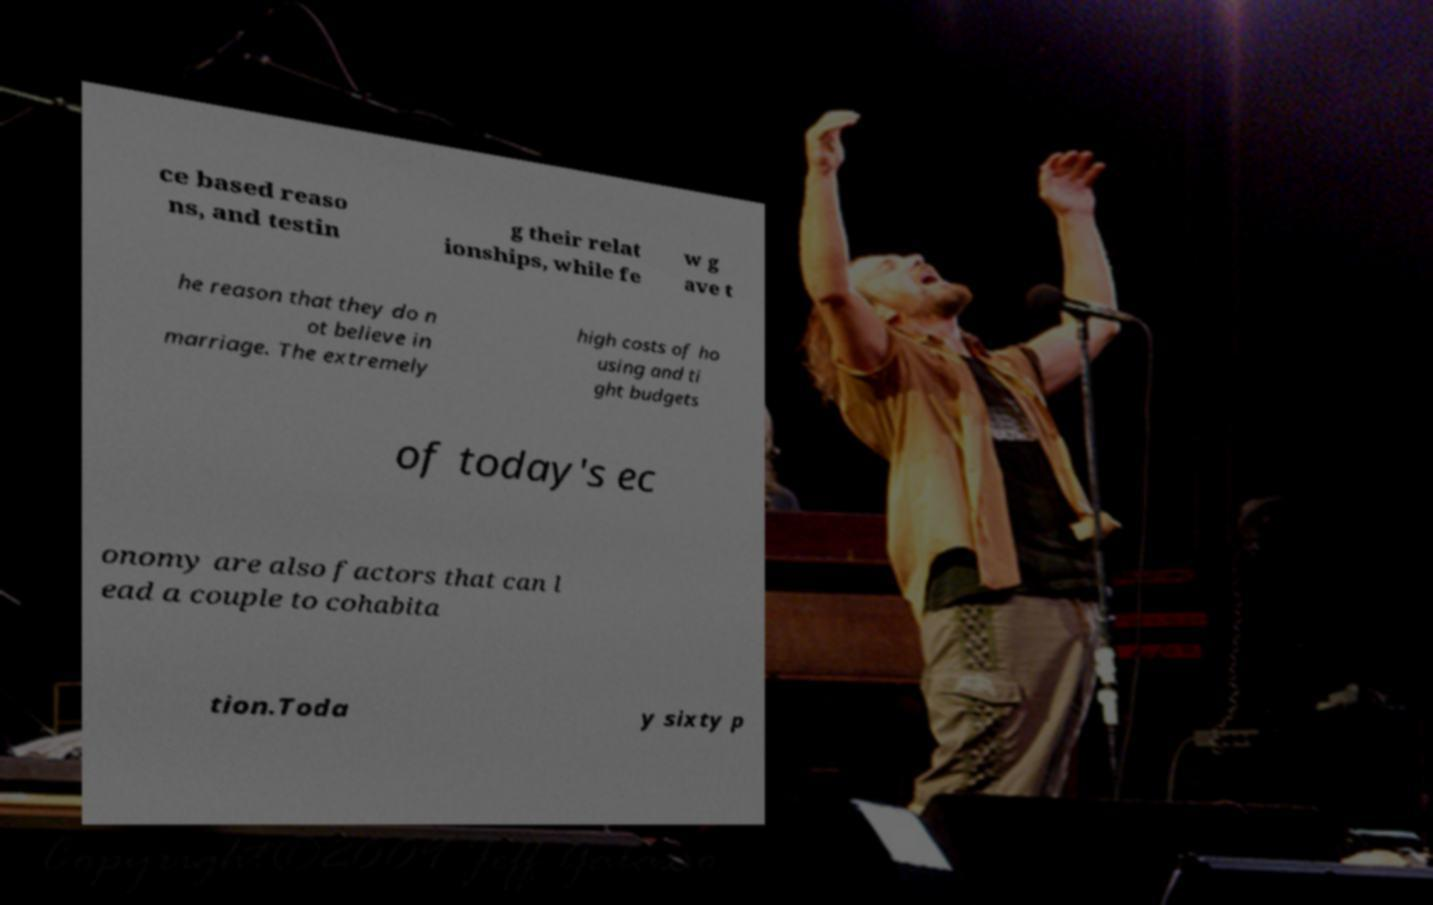What messages or text are displayed in this image? I need them in a readable, typed format. ce based reaso ns, and testin g their relat ionships, while fe w g ave t he reason that they do n ot believe in marriage. The extremely high costs of ho using and ti ght budgets of today's ec onomy are also factors that can l ead a couple to cohabita tion.Toda y sixty p 